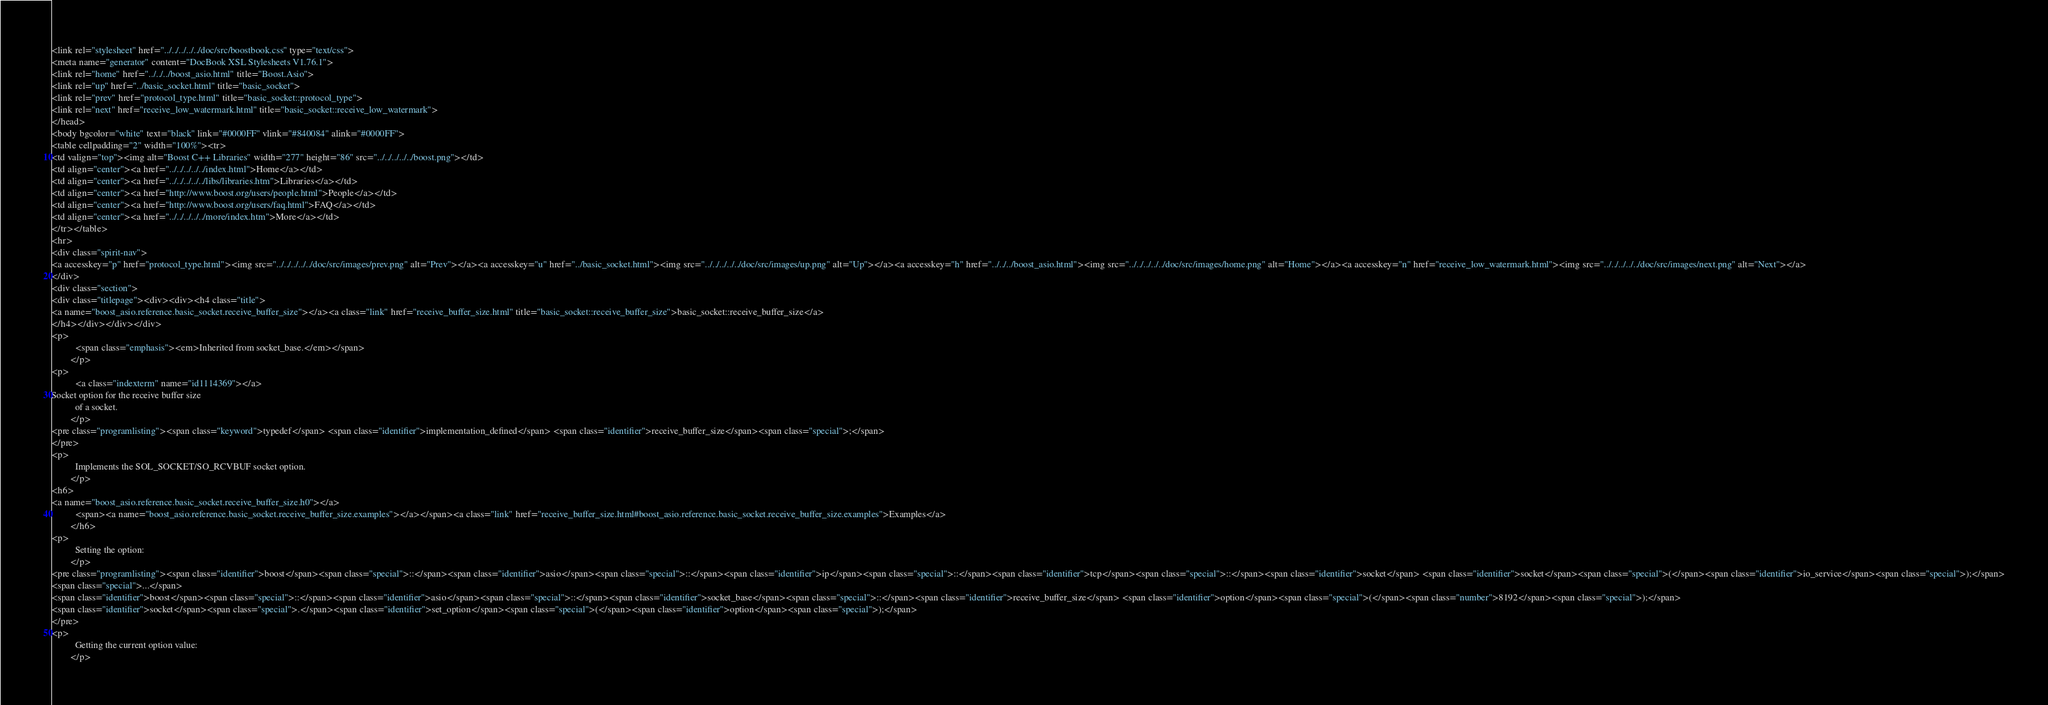<code> <loc_0><loc_0><loc_500><loc_500><_HTML_><link rel="stylesheet" href="../../../../../doc/src/boostbook.css" type="text/css">
<meta name="generator" content="DocBook XSL Stylesheets V1.76.1">
<link rel="home" href="../../../boost_asio.html" title="Boost.Asio">
<link rel="up" href="../basic_socket.html" title="basic_socket">
<link rel="prev" href="protocol_type.html" title="basic_socket::protocol_type">
<link rel="next" href="receive_low_watermark.html" title="basic_socket::receive_low_watermark">
</head>
<body bgcolor="white" text="black" link="#0000FF" vlink="#840084" alink="#0000FF">
<table cellpadding="2" width="100%"><tr>
<td valign="top"><img alt="Boost C++ Libraries" width="277" height="86" src="../../../../../boost.png"></td>
<td align="center"><a href="../../../../../index.html">Home</a></td>
<td align="center"><a href="../../../../../libs/libraries.htm">Libraries</a></td>
<td align="center"><a href="http://www.boost.org/users/people.html">People</a></td>
<td align="center"><a href="http://www.boost.org/users/faq.html">FAQ</a></td>
<td align="center"><a href="../../../../../more/index.htm">More</a></td>
</tr></table>
<hr>
<div class="spirit-nav">
<a accesskey="p" href="protocol_type.html"><img src="../../../../../doc/src/images/prev.png" alt="Prev"></a><a accesskey="u" href="../basic_socket.html"><img src="../../../../../doc/src/images/up.png" alt="Up"></a><a accesskey="h" href="../../../boost_asio.html"><img src="../../../../../doc/src/images/home.png" alt="Home"></a><a accesskey="n" href="receive_low_watermark.html"><img src="../../../../../doc/src/images/next.png" alt="Next"></a>
</div>
<div class="section">
<div class="titlepage"><div><div><h4 class="title">
<a name="boost_asio.reference.basic_socket.receive_buffer_size"></a><a class="link" href="receive_buffer_size.html" title="basic_socket::receive_buffer_size">basic_socket::receive_buffer_size</a>
</h4></div></div></div>
<p>
          <span class="emphasis"><em>Inherited from socket_base.</em></span>
        </p>
<p>
          <a class="indexterm" name="id1114369"></a> 
Socket option for the receive buffer size
          of a socket.
        </p>
<pre class="programlisting"><span class="keyword">typedef</span> <span class="identifier">implementation_defined</span> <span class="identifier">receive_buffer_size</span><span class="special">;</span>
</pre>
<p>
          Implements the SOL_SOCKET/SO_RCVBUF socket option.
        </p>
<h6>
<a name="boost_asio.reference.basic_socket.receive_buffer_size.h0"></a>
          <span><a name="boost_asio.reference.basic_socket.receive_buffer_size.examples"></a></span><a class="link" href="receive_buffer_size.html#boost_asio.reference.basic_socket.receive_buffer_size.examples">Examples</a>
        </h6>
<p>
          Setting the option:
        </p>
<pre class="programlisting"><span class="identifier">boost</span><span class="special">::</span><span class="identifier">asio</span><span class="special">::</span><span class="identifier">ip</span><span class="special">::</span><span class="identifier">tcp</span><span class="special">::</span><span class="identifier">socket</span> <span class="identifier">socket</span><span class="special">(</span><span class="identifier">io_service</span><span class="special">);</span>
<span class="special">...</span>
<span class="identifier">boost</span><span class="special">::</span><span class="identifier">asio</span><span class="special">::</span><span class="identifier">socket_base</span><span class="special">::</span><span class="identifier">receive_buffer_size</span> <span class="identifier">option</span><span class="special">(</span><span class="number">8192</span><span class="special">);</span>
<span class="identifier">socket</span><span class="special">.</span><span class="identifier">set_option</span><span class="special">(</span><span class="identifier">option</span><span class="special">);</span>
</pre>
<p>
          Getting the current option value:
        </p></code> 